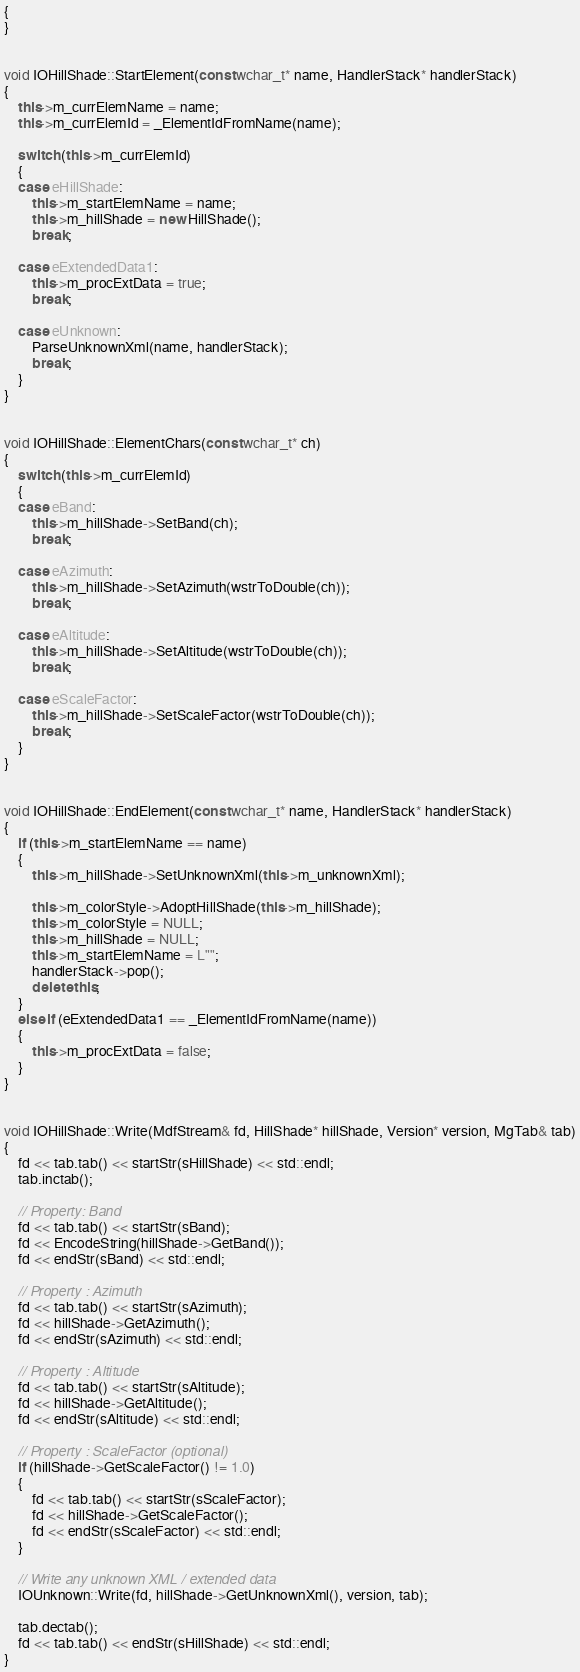<code> <loc_0><loc_0><loc_500><loc_500><_C++_>{
}


void IOHillShade::StartElement(const wchar_t* name, HandlerStack* handlerStack)
{
    this->m_currElemName = name;
    this->m_currElemId = _ElementIdFromName(name);

    switch (this->m_currElemId)
    {
    case eHillShade:
        this->m_startElemName = name;
        this->m_hillShade = new HillShade();
        break;

    case eExtendedData1:
        this->m_procExtData = true;
        break;

    case eUnknown:
        ParseUnknownXml(name, handlerStack);
        break;
    }
}


void IOHillShade::ElementChars(const wchar_t* ch)
{
    switch (this->m_currElemId)
    {
    case eBand:
        this->m_hillShade->SetBand(ch);
        break;

    case eAzimuth:
        this->m_hillShade->SetAzimuth(wstrToDouble(ch));
        break;

    case eAltitude:
        this->m_hillShade->SetAltitude(wstrToDouble(ch));
        break;

    case eScaleFactor:
        this->m_hillShade->SetScaleFactor(wstrToDouble(ch));
        break;
    }
}


void IOHillShade::EndElement(const wchar_t* name, HandlerStack* handlerStack)
{
    if (this->m_startElemName == name)
    {
        this->m_hillShade->SetUnknownXml(this->m_unknownXml);

        this->m_colorStyle->AdoptHillShade(this->m_hillShade);
        this->m_colorStyle = NULL;
        this->m_hillShade = NULL;
        this->m_startElemName = L"";
        handlerStack->pop();
        delete this;
    }
    else if (eExtendedData1 == _ElementIdFromName(name))
    {
        this->m_procExtData = false;
    }
}


void IOHillShade::Write(MdfStream& fd, HillShade* hillShade, Version* version, MgTab& tab)
{
    fd << tab.tab() << startStr(sHillShade) << std::endl;
    tab.inctab();

    // Property: Band
    fd << tab.tab() << startStr(sBand);
    fd << EncodeString(hillShade->GetBand());
    fd << endStr(sBand) << std::endl;

    // Property : Azimuth
    fd << tab.tab() << startStr(sAzimuth);
    fd << hillShade->GetAzimuth();
    fd << endStr(sAzimuth) << std::endl;

    // Property : Altitude
    fd << tab.tab() << startStr(sAltitude);
    fd << hillShade->GetAltitude();
    fd << endStr(sAltitude) << std::endl;

    // Property : ScaleFactor (optional)
    if (hillShade->GetScaleFactor() != 1.0)
    {
        fd << tab.tab() << startStr(sScaleFactor);
        fd << hillShade->GetScaleFactor();
        fd << endStr(sScaleFactor) << std::endl;
    }

    // Write any unknown XML / extended data
    IOUnknown::Write(fd, hillShade->GetUnknownXml(), version, tab);

    tab.dectab();
    fd << tab.tab() << endStr(sHillShade) << std::endl;
}
</code> 